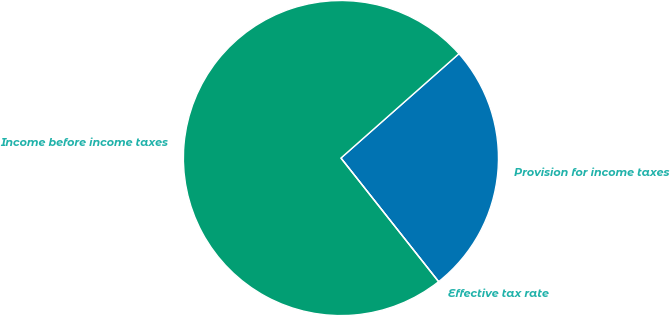Convert chart. <chart><loc_0><loc_0><loc_500><loc_500><pie_chart><fcel>Provision for income taxes<fcel>Income before income taxes<fcel>Effective tax rate<nl><fcel>25.88%<fcel>74.11%<fcel>0.0%<nl></chart> 